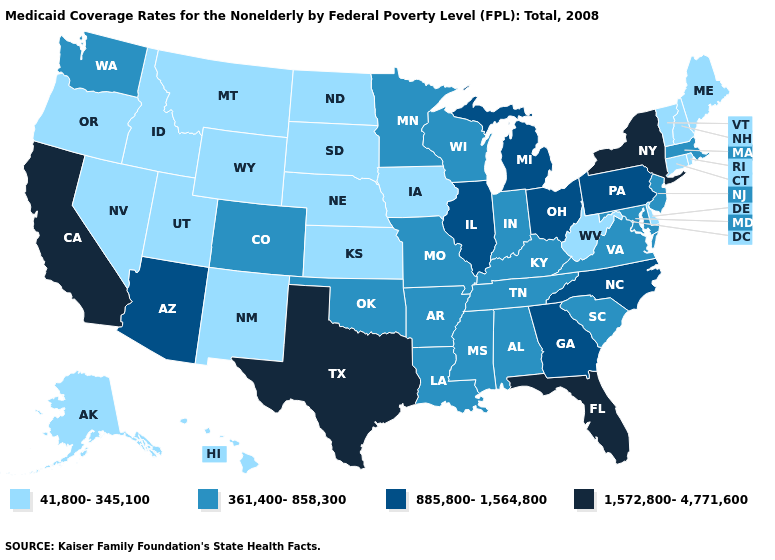Name the states that have a value in the range 1,572,800-4,771,600?
Short answer required. California, Florida, New York, Texas. What is the value of California?
Keep it brief. 1,572,800-4,771,600. Is the legend a continuous bar?
Write a very short answer. No. What is the value of Nebraska?
Short answer required. 41,800-345,100. Name the states that have a value in the range 41,800-345,100?
Give a very brief answer. Alaska, Connecticut, Delaware, Hawaii, Idaho, Iowa, Kansas, Maine, Montana, Nebraska, Nevada, New Hampshire, New Mexico, North Dakota, Oregon, Rhode Island, South Dakota, Utah, Vermont, West Virginia, Wyoming. Does Pennsylvania have the highest value in the Northeast?
Answer briefly. No. What is the lowest value in the USA?
Keep it brief. 41,800-345,100. Which states have the lowest value in the Northeast?
Answer briefly. Connecticut, Maine, New Hampshire, Rhode Island, Vermont. What is the value of Nevada?
Concise answer only. 41,800-345,100. Name the states that have a value in the range 1,572,800-4,771,600?
Write a very short answer. California, Florida, New York, Texas. Which states hav the highest value in the South?
Keep it brief. Florida, Texas. What is the value of Illinois?
Keep it brief. 885,800-1,564,800. Does Connecticut have the lowest value in the USA?
Be succinct. Yes. What is the highest value in the USA?
Give a very brief answer. 1,572,800-4,771,600. Name the states that have a value in the range 361,400-858,300?
Be succinct. Alabama, Arkansas, Colorado, Indiana, Kentucky, Louisiana, Maryland, Massachusetts, Minnesota, Mississippi, Missouri, New Jersey, Oklahoma, South Carolina, Tennessee, Virginia, Washington, Wisconsin. 